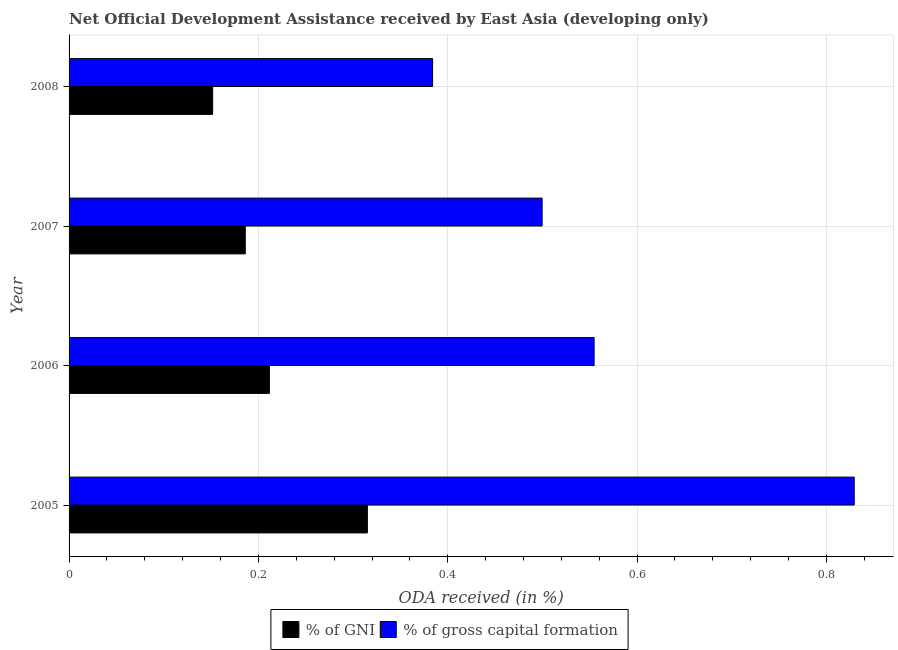How many different coloured bars are there?
Offer a very short reply. 2. How many groups of bars are there?
Your answer should be very brief. 4. Are the number of bars per tick equal to the number of legend labels?
Provide a succinct answer. Yes. What is the label of the 1st group of bars from the top?
Offer a terse response. 2008. In how many cases, is the number of bars for a given year not equal to the number of legend labels?
Your answer should be very brief. 0. What is the oda received as percentage of gni in 2007?
Provide a succinct answer. 0.19. Across all years, what is the maximum oda received as percentage of gross capital formation?
Ensure brevity in your answer.  0.83. Across all years, what is the minimum oda received as percentage of gni?
Make the answer very short. 0.15. What is the total oda received as percentage of gni in the graph?
Your answer should be compact. 0.86. What is the difference between the oda received as percentage of gross capital formation in 2006 and that in 2007?
Your answer should be compact. 0.06. What is the difference between the oda received as percentage of gni in 2006 and the oda received as percentage of gross capital formation in 2007?
Your response must be concise. -0.29. What is the average oda received as percentage of gross capital formation per year?
Make the answer very short. 0.57. In the year 2007, what is the difference between the oda received as percentage of gross capital formation and oda received as percentage of gni?
Ensure brevity in your answer.  0.31. What is the ratio of the oda received as percentage of gni in 2005 to that in 2008?
Your answer should be compact. 2.08. Is the difference between the oda received as percentage of gross capital formation in 2005 and 2007 greater than the difference between the oda received as percentage of gni in 2005 and 2007?
Keep it short and to the point. Yes. What is the difference between the highest and the second highest oda received as percentage of gni?
Give a very brief answer. 0.1. What is the difference between the highest and the lowest oda received as percentage of gni?
Your answer should be compact. 0.16. In how many years, is the oda received as percentage of gni greater than the average oda received as percentage of gni taken over all years?
Ensure brevity in your answer.  1. Is the sum of the oda received as percentage of gross capital formation in 2007 and 2008 greater than the maximum oda received as percentage of gni across all years?
Offer a terse response. Yes. What does the 1st bar from the top in 2006 represents?
Provide a short and direct response. % of gross capital formation. What does the 2nd bar from the bottom in 2008 represents?
Provide a short and direct response. % of gross capital formation. Are all the bars in the graph horizontal?
Your answer should be very brief. Yes. How many years are there in the graph?
Keep it short and to the point. 4. Does the graph contain any zero values?
Your answer should be very brief. No. Does the graph contain grids?
Make the answer very short. Yes. How are the legend labels stacked?
Make the answer very short. Horizontal. What is the title of the graph?
Provide a short and direct response. Net Official Development Assistance received by East Asia (developing only). Does "Research and Development" appear as one of the legend labels in the graph?
Give a very brief answer. No. What is the label or title of the X-axis?
Provide a short and direct response. ODA received (in %). What is the ODA received (in %) of % of GNI in 2005?
Make the answer very short. 0.32. What is the ODA received (in %) of % of gross capital formation in 2005?
Your answer should be compact. 0.83. What is the ODA received (in %) of % of GNI in 2006?
Make the answer very short. 0.21. What is the ODA received (in %) in % of gross capital formation in 2006?
Offer a terse response. 0.55. What is the ODA received (in %) in % of GNI in 2007?
Provide a succinct answer. 0.19. What is the ODA received (in %) of % of gross capital formation in 2007?
Give a very brief answer. 0.5. What is the ODA received (in %) in % of GNI in 2008?
Keep it short and to the point. 0.15. What is the ODA received (in %) in % of gross capital formation in 2008?
Provide a short and direct response. 0.38. Across all years, what is the maximum ODA received (in %) of % of GNI?
Make the answer very short. 0.32. Across all years, what is the maximum ODA received (in %) in % of gross capital formation?
Give a very brief answer. 0.83. Across all years, what is the minimum ODA received (in %) of % of GNI?
Your response must be concise. 0.15. Across all years, what is the minimum ODA received (in %) of % of gross capital formation?
Ensure brevity in your answer.  0.38. What is the total ODA received (in %) of % of GNI in the graph?
Make the answer very short. 0.86. What is the total ODA received (in %) of % of gross capital formation in the graph?
Your answer should be compact. 2.27. What is the difference between the ODA received (in %) of % of GNI in 2005 and that in 2006?
Provide a short and direct response. 0.1. What is the difference between the ODA received (in %) in % of gross capital formation in 2005 and that in 2006?
Your answer should be very brief. 0.27. What is the difference between the ODA received (in %) in % of GNI in 2005 and that in 2007?
Offer a very short reply. 0.13. What is the difference between the ODA received (in %) of % of gross capital formation in 2005 and that in 2007?
Provide a succinct answer. 0.33. What is the difference between the ODA received (in %) in % of GNI in 2005 and that in 2008?
Provide a short and direct response. 0.16. What is the difference between the ODA received (in %) in % of gross capital formation in 2005 and that in 2008?
Your response must be concise. 0.45. What is the difference between the ODA received (in %) in % of GNI in 2006 and that in 2007?
Keep it short and to the point. 0.03. What is the difference between the ODA received (in %) in % of gross capital formation in 2006 and that in 2007?
Provide a short and direct response. 0.05. What is the difference between the ODA received (in %) of % of GNI in 2006 and that in 2008?
Ensure brevity in your answer.  0.06. What is the difference between the ODA received (in %) of % of gross capital formation in 2006 and that in 2008?
Your answer should be compact. 0.17. What is the difference between the ODA received (in %) in % of GNI in 2007 and that in 2008?
Provide a succinct answer. 0.03. What is the difference between the ODA received (in %) of % of gross capital formation in 2007 and that in 2008?
Make the answer very short. 0.12. What is the difference between the ODA received (in %) of % of GNI in 2005 and the ODA received (in %) of % of gross capital formation in 2006?
Provide a succinct answer. -0.24. What is the difference between the ODA received (in %) in % of GNI in 2005 and the ODA received (in %) in % of gross capital formation in 2007?
Offer a very short reply. -0.18. What is the difference between the ODA received (in %) in % of GNI in 2005 and the ODA received (in %) in % of gross capital formation in 2008?
Your answer should be compact. -0.07. What is the difference between the ODA received (in %) in % of GNI in 2006 and the ODA received (in %) in % of gross capital formation in 2007?
Ensure brevity in your answer.  -0.29. What is the difference between the ODA received (in %) in % of GNI in 2006 and the ODA received (in %) in % of gross capital formation in 2008?
Ensure brevity in your answer.  -0.17. What is the difference between the ODA received (in %) in % of GNI in 2007 and the ODA received (in %) in % of gross capital formation in 2008?
Ensure brevity in your answer.  -0.2. What is the average ODA received (in %) in % of GNI per year?
Your response must be concise. 0.22. What is the average ODA received (in %) in % of gross capital formation per year?
Your response must be concise. 0.57. In the year 2005, what is the difference between the ODA received (in %) of % of GNI and ODA received (in %) of % of gross capital formation?
Provide a succinct answer. -0.51. In the year 2006, what is the difference between the ODA received (in %) in % of GNI and ODA received (in %) in % of gross capital formation?
Give a very brief answer. -0.34. In the year 2007, what is the difference between the ODA received (in %) of % of GNI and ODA received (in %) of % of gross capital formation?
Offer a very short reply. -0.31. In the year 2008, what is the difference between the ODA received (in %) of % of GNI and ODA received (in %) of % of gross capital formation?
Give a very brief answer. -0.23. What is the ratio of the ODA received (in %) in % of GNI in 2005 to that in 2006?
Your response must be concise. 1.49. What is the ratio of the ODA received (in %) in % of gross capital formation in 2005 to that in 2006?
Your response must be concise. 1.5. What is the ratio of the ODA received (in %) in % of GNI in 2005 to that in 2007?
Provide a short and direct response. 1.69. What is the ratio of the ODA received (in %) of % of gross capital formation in 2005 to that in 2007?
Make the answer very short. 1.66. What is the ratio of the ODA received (in %) of % of GNI in 2005 to that in 2008?
Your answer should be very brief. 2.08. What is the ratio of the ODA received (in %) of % of gross capital formation in 2005 to that in 2008?
Provide a short and direct response. 2.16. What is the ratio of the ODA received (in %) in % of GNI in 2006 to that in 2007?
Your response must be concise. 1.14. What is the ratio of the ODA received (in %) of % of gross capital formation in 2006 to that in 2007?
Your response must be concise. 1.11. What is the ratio of the ODA received (in %) in % of GNI in 2006 to that in 2008?
Provide a succinct answer. 1.4. What is the ratio of the ODA received (in %) of % of gross capital formation in 2006 to that in 2008?
Provide a short and direct response. 1.44. What is the ratio of the ODA received (in %) of % of GNI in 2007 to that in 2008?
Your answer should be very brief. 1.23. What is the ratio of the ODA received (in %) of % of gross capital formation in 2007 to that in 2008?
Your answer should be compact. 1.3. What is the difference between the highest and the second highest ODA received (in %) of % of GNI?
Give a very brief answer. 0.1. What is the difference between the highest and the second highest ODA received (in %) of % of gross capital formation?
Ensure brevity in your answer.  0.27. What is the difference between the highest and the lowest ODA received (in %) in % of GNI?
Provide a succinct answer. 0.16. What is the difference between the highest and the lowest ODA received (in %) in % of gross capital formation?
Ensure brevity in your answer.  0.45. 